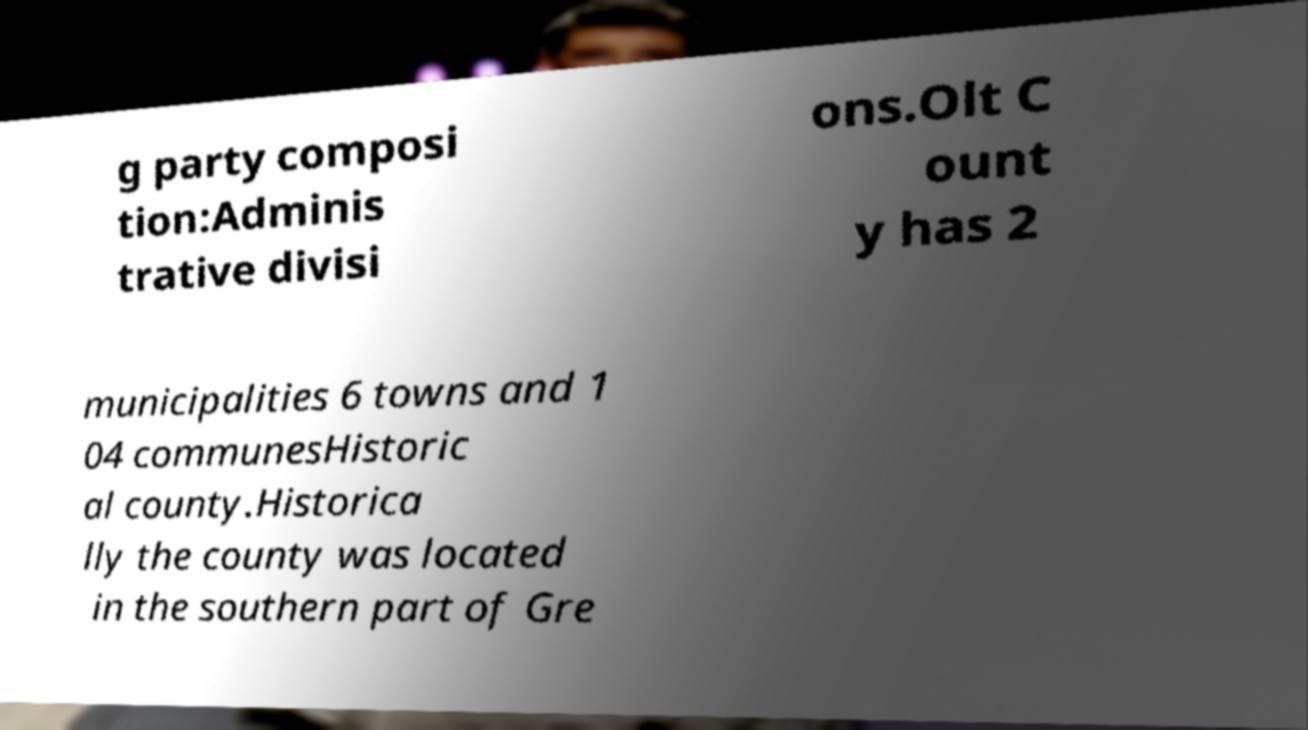Can you read and provide the text displayed in the image?This photo seems to have some interesting text. Can you extract and type it out for me? g party composi tion:Adminis trative divisi ons.Olt C ount y has 2 municipalities 6 towns and 1 04 communesHistoric al county.Historica lly the county was located in the southern part of Gre 